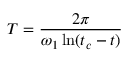Convert formula to latex. <formula><loc_0><loc_0><loc_500><loc_500>T = \frac { 2 \pi } { \omega _ { 1 } \ln ( t _ { c } - t ) }</formula> 